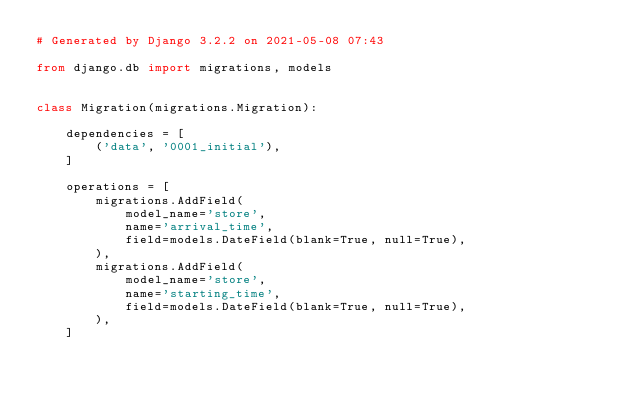Convert code to text. <code><loc_0><loc_0><loc_500><loc_500><_Python_># Generated by Django 3.2.2 on 2021-05-08 07:43

from django.db import migrations, models


class Migration(migrations.Migration):

    dependencies = [
        ('data', '0001_initial'),
    ]

    operations = [
        migrations.AddField(
            model_name='store',
            name='arrival_time',
            field=models.DateField(blank=True, null=True),
        ),
        migrations.AddField(
            model_name='store',
            name='starting_time',
            field=models.DateField(blank=True, null=True),
        ),
    ]
</code> 